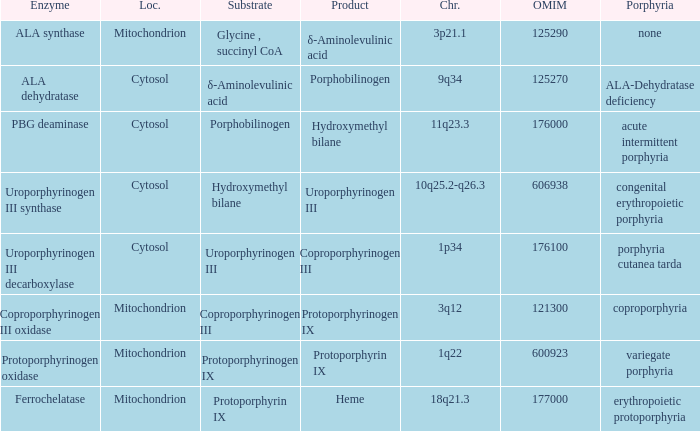What is protoporphyrin ix's substrate? Protoporphyrinogen IX. 